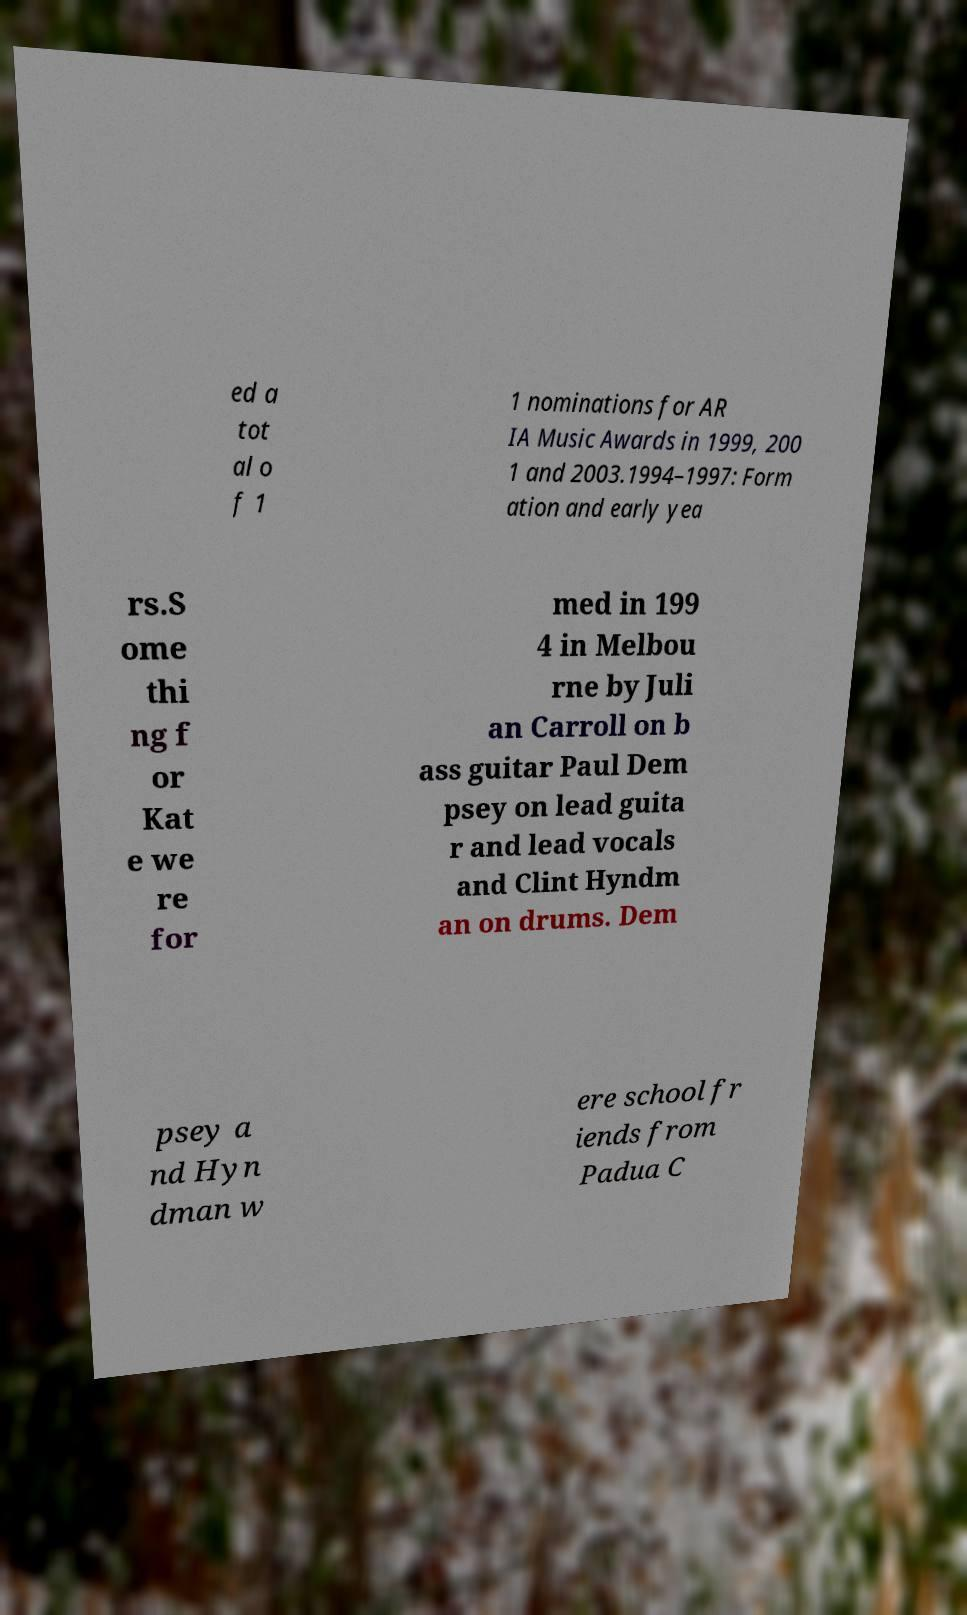What messages or text are displayed in this image? I need them in a readable, typed format. ed a tot al o f 1 1 nominations for AR IA Music Awards in 1999, 200 1 and 2003.1994–1997: Form ation and early yea rs.S ome thi ng f or Kat e we re for med in 199 4 in Melbou rne by Juli an Carroll on b ass guitar Paul Dem psey on lead guita r and lead vocals and Clint Hyndm an on drums. Dem psey a nd Hyn dman w ere school fr iends from Padua C 